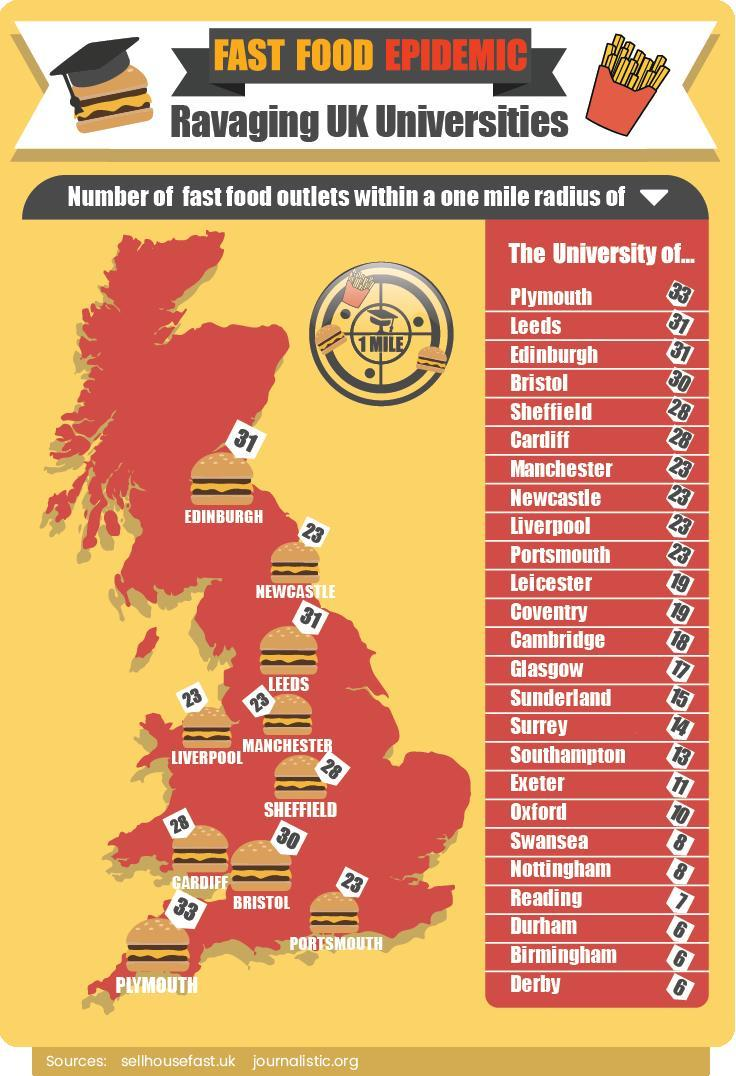What is the name of the place in the extreme south of UK?
Answer the question with a short phrase. Plymouth How many places in UK have 6 Fast Food Outlets within one mile radius? 3 Which are the places in UK with second most number of Fast food outlets? Leeds, Edinburgh Which food item is shown multiple times in the map of UK showing Fast food outlets- sandwich, burger, pop corn, pizza? burger How many places in UK have 28 Fast Food Outlets within one mile radius? 2 What is the name of the place that comes in middle of Edinburgh and Leeds? Newcastle How many places in UK have 31 Fast Food Outlets within one mile radius? 2 